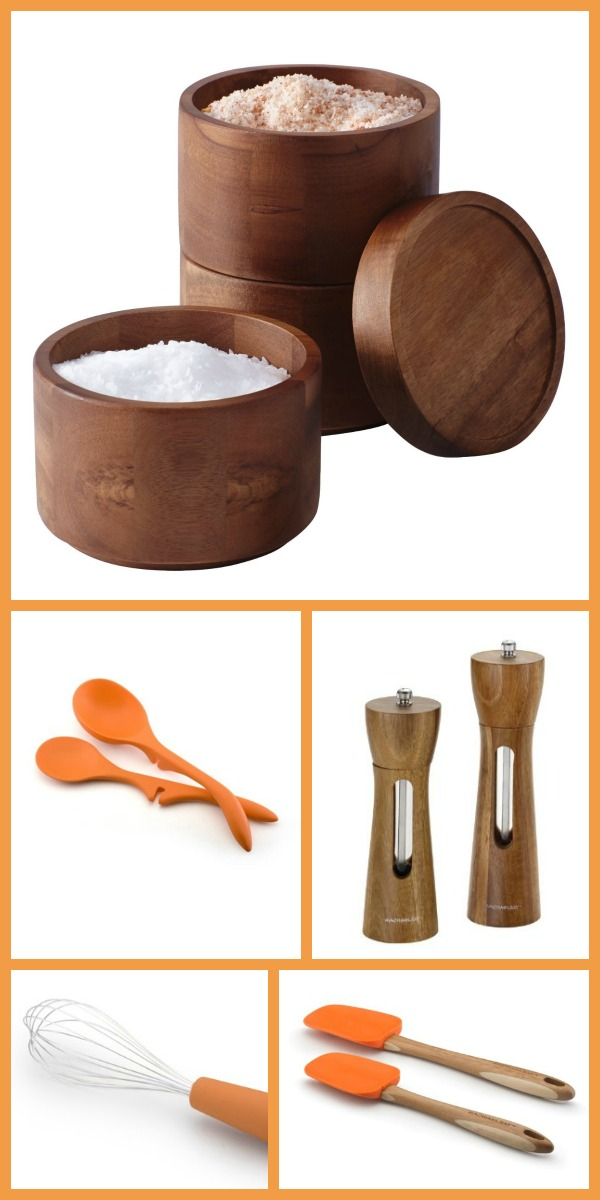Are the silicone utensils heat-resistant and what is the maximum temperature they can withstand? Silicone kitchen utensils, like the ones shown in the image, are generally designed to be heat-resistant. They can typically withstand temperatures up to around 500°F (260°C). However, for the exact maximum temperature, it is best to refer to the manufacturer's specifications. 